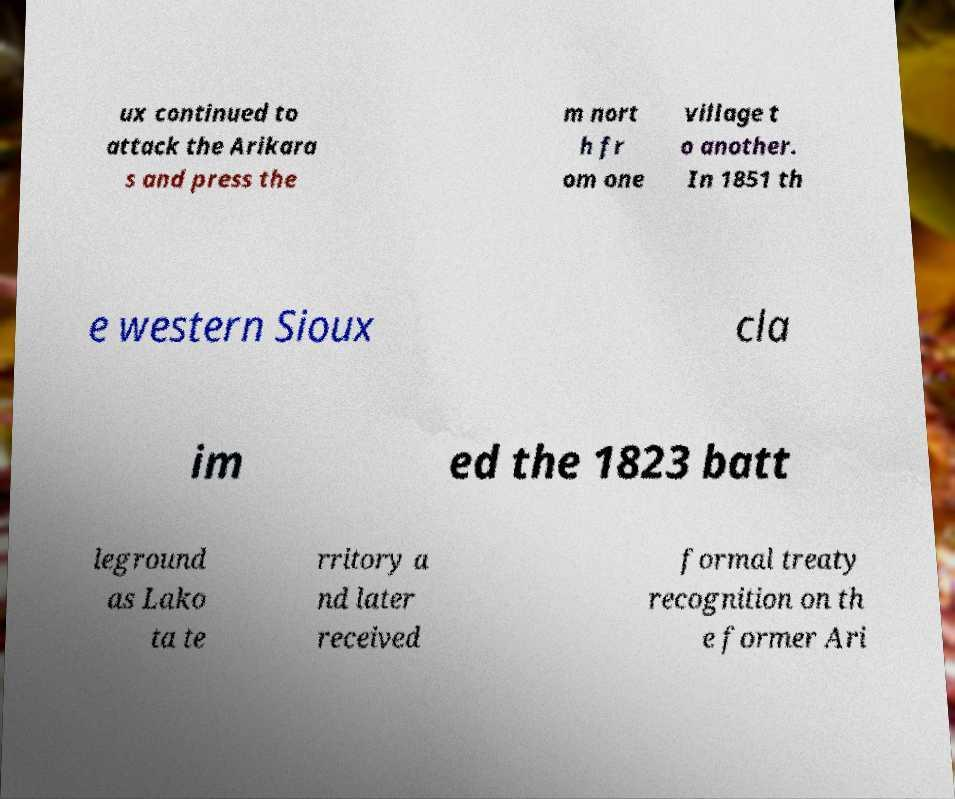For documentation purposes, I need the text within this image transcribed. Could you provide that? ux continued to attack the Arikara s and press the m nort h fr om one village t o another. In 1851 th e western Sioux cla im ed the 1823 batt leground as Lako ta te rritory a nd later received formal treaty recognition on th e former Ari 